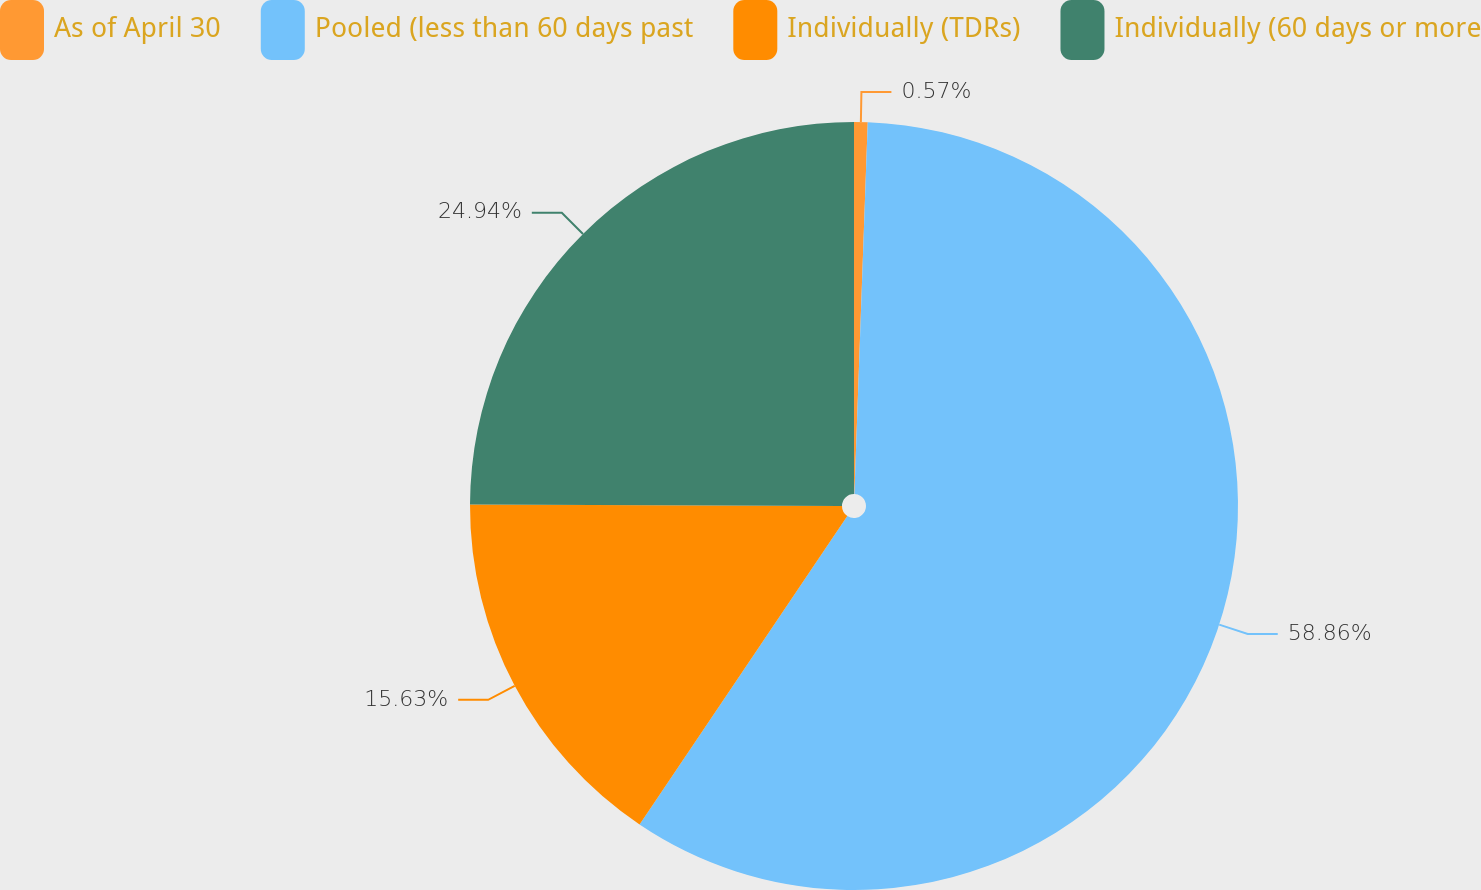Convert chart to OTSL. <chart><loc_0><loc_0><loc_500><loc_500><pie_chart><fcel>As of April 30<fcel>Pooled (less than 60 days past<fcel>Individually (TDRs)<fcel>Individually (60 days or more<nl><fcel>0.57%<fcel>58.86%<fcel>15.63%<fcel>24.94%<nl></chart> 